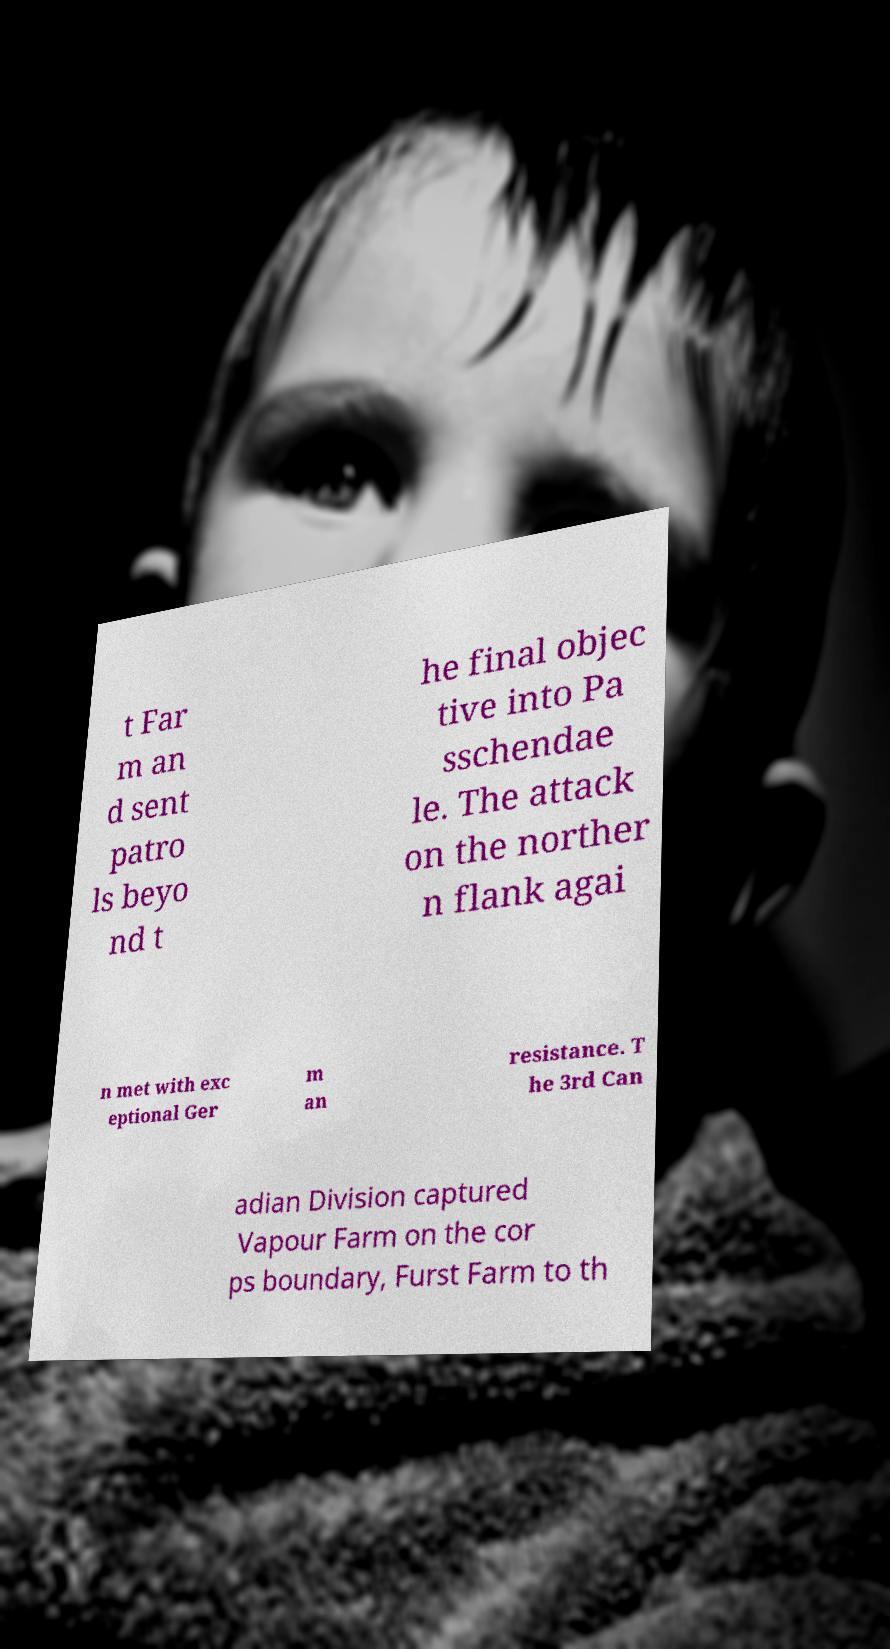Could you assist in decoding the text presented in this image and type it out clearly? t Far m an d sent patro ls beyo nd t he final objec tive into Pa sschendae le. The attack on the norther n flank agai n met with exc eptional Ger m an resistance. T he 3rd Can adian Division captured Vapour Farm on the cor ps boundary, Furst Farm to th 